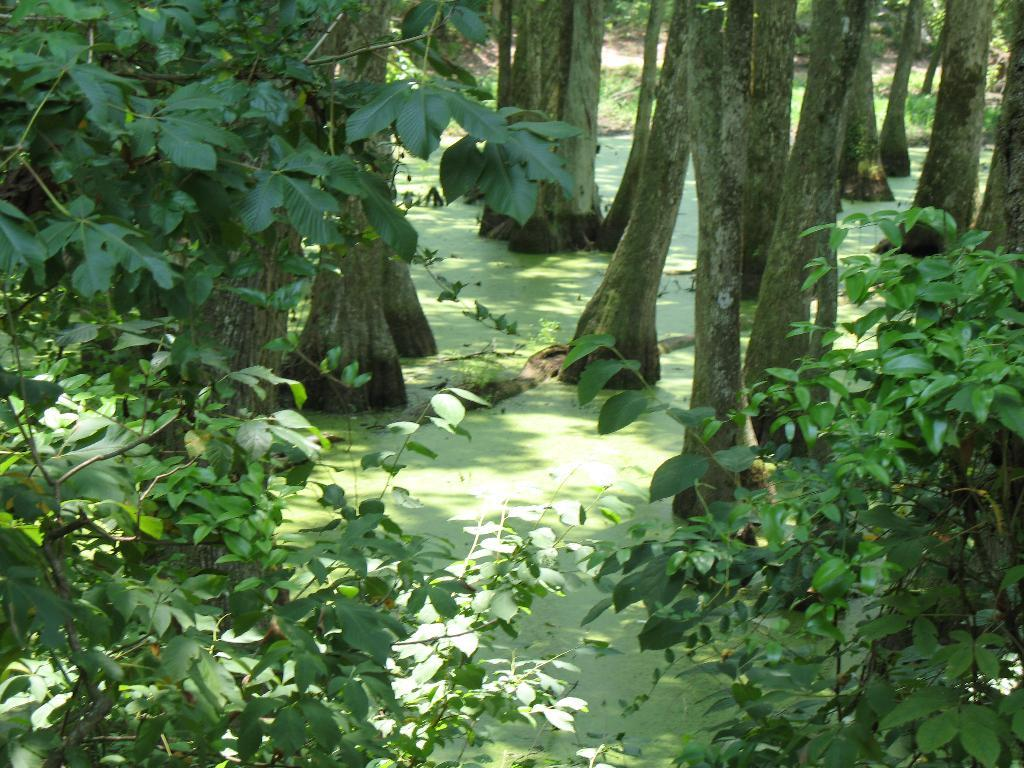What type of vegetation can be seen in the image? There are trees in the image. What is visible at the bottom of the image? There is water visible at the bottom of the image. Can you describe any specific part of a tree in the image? There is a tree branch in the image. What type of ground cover is visible in the background of the image? There is grass visible in the background of the image. What type of treatment is the robin receiving in the image? There is no robin present in the image, so it is not possible to determine if any treatment is being received. 